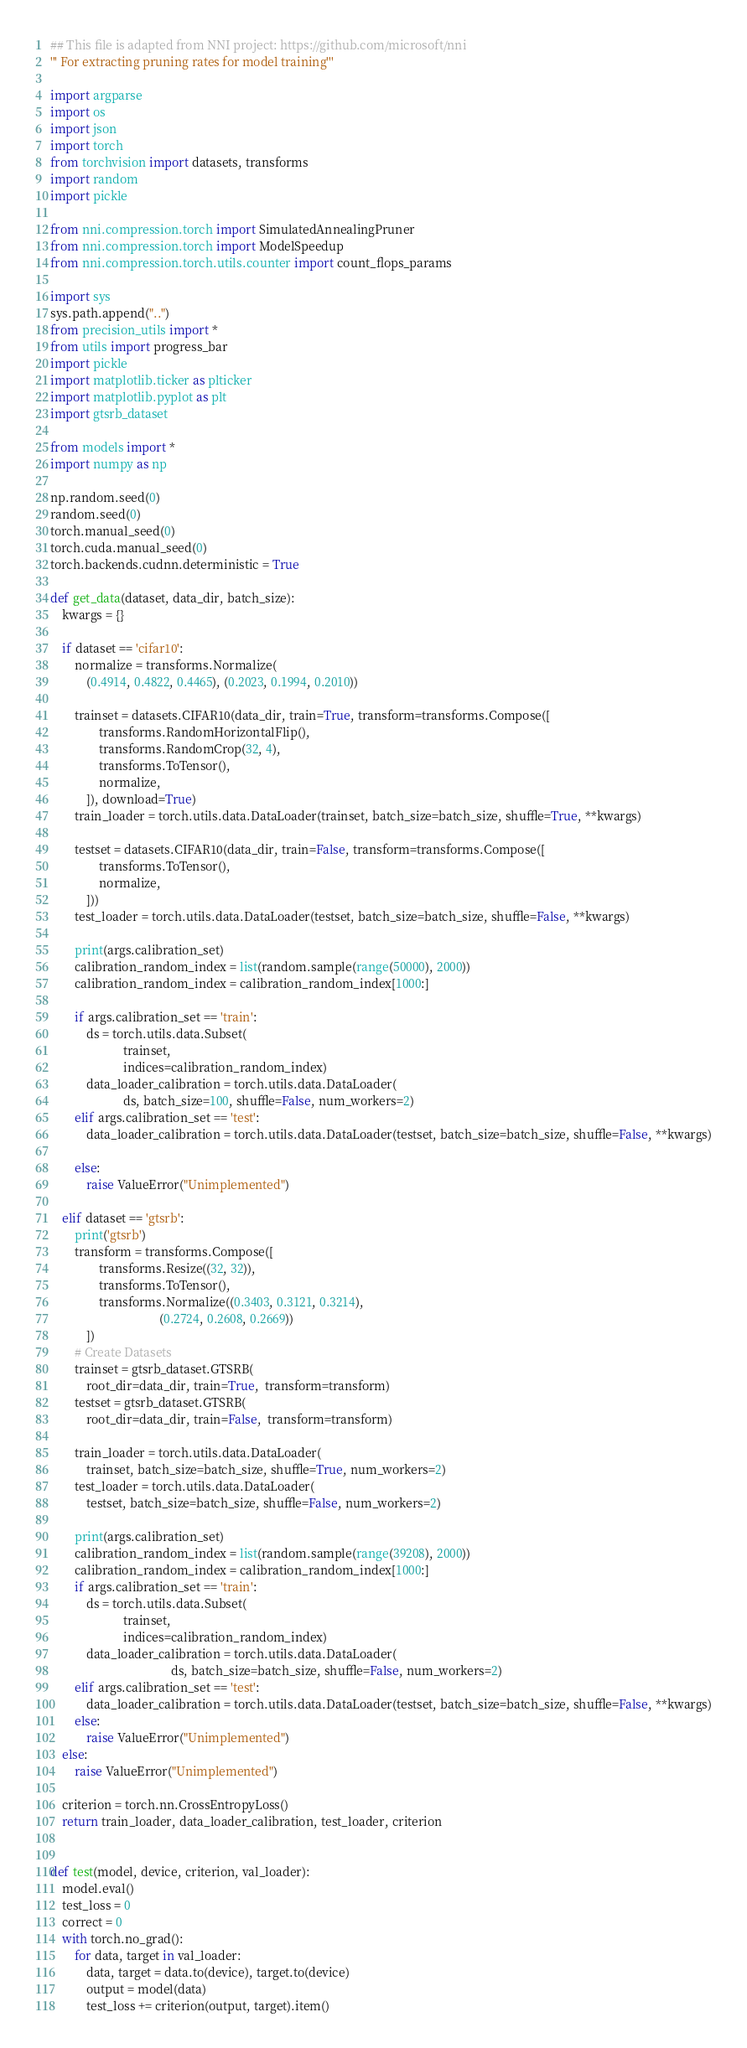Convert code to text. <code><loc_0><loc_0><loc_500><loc_500><_Python_>## This file is adapted from NNI project: https://github.com/microsoft/nni
''' For extracting pruning rates for model training'''

import argparse
import os
import json
import torch
from torchvision import datasets, transforms
import random
import pickle

from nni.compression.torch import SimulatedAnnealingPruner
from nni.compression.torch import ModelSpeedup
from nni.compression.torch.utils.counter import count_flops_params

import sys
sys.path.append("..")
from precision_utils import *
from utils import progress_bar
import pickle
import matplotlib.ticker as plticker
import matplotlib.pyplot as plt 
import gtsrb_dataset

from models import *
import numpy as np

np.random.seed(0)
random.seed(0)
torch.manual_seed(0)
torch.cuda.manual_seed(0)
torch.backends.cudnn.deterministic = True

def get_data(dataset, data_dir, batch_size):
    kwargs = {}

    if dataset == 'cifar10':
        normalize = transforms.Normalize(
            (0.4914, 0.4822, 0.4465), (0.2023, 0.1994, 0.2010))

        trainset = datasets.CIFAR10(data_dir, train=True, transform=transforms.Compose([
                transforms.RandomHorizontalFlip(),
                transforms.RandomCrop(32, 4),
                transforms.ToTensor(),
                normalize,
            ]), download=True)
        train_loader = torch.utils.data.DataLoader(trainset, batch_size=batch_size, shuffle=True, **kwargs)

        testset = datasets.CIFAR10(data_dir, train=False, transform=transforms.Compose([
                transforms.ToTensor(),
                normalize,
            ]))
        test_loader = torch.utils.data.DataLoader(testset, batch_size=batch_size, shuffle=False, **kwargs)

        print(args.calibration_set)
        calibration_random_index = list(random.sample(range(50000), 2000))
        calibration_random_index = calibration_random_index[1000:]

        if args.calibration_set == 'train':
            ds = torch.utils.data.Subset(
                        trainset,
                        indices=calibration_random_index)
            data_loader_calibration = torch.utils.data.DataLoader(
                        ds, batch_size=100, shuffle=False, num_workers=2)
        elif args.calibration_set == 'test':
            data_loader_calibration = torch.utils.data.DataLoader(testset, batch_size=batch_size, shuffle=False, **kwargs)

        else:
            raise ValueError("Unimplemented")

    elif dataset == 'gtsrb':
        print('gtsrb')
        transform = transforms.Compose([
                transforms.Resize((32, 32)),
                transforms.ToTensor(),
                transforms.Normalize((0.3403, 0.3121, 0.3214),
                                    (0.2724, 0.2608, 0.2669))
            ])
        # Create Datasets
        trainset = gtsrb_dataset.GTSRB(
            root_dir=data_dir, train=True,  transform=transform)
        testset = gtsrb_dataset.GTSRB(
            root_dir=data_dir, train=False,  transform=transform)

        train_loader = torch.utils.data.DataLoader(
            trainset, batch_size=batch_size, shuffle=True, num_workers=2)
        test_loader = torch.utils.data.DataLoader(
            testset, batch_size=batch_size, shuffle=False, num_workers=2)

        print(args.calibration_set)
        calibration_random_index = list(random.sample(range(39208), 2000))
        calibration_random_index = calibration_random_index[1000:]
        if args.calibration_set == 'train':
            ds = torch.utils.data.Subset(
                        trainset,
                        indices=calibration_random_index)
            data_loader_calibration = torch.utils.data.DataLoader(
                                        ds, batch_size=batch_size, shuffle=False, num_workers=2)
        elif args.calibration_set == 'test':
            data_loader_calibration = torch.utils.data.DataLoader(testset, batch_size=batch_size, shuffle=False, **kwargs)
        else:
            raise ValueError("Unimplemented")
    else:
        raise ValueError("Unimplemented")

    criterion = torch.nn.CrossEntropyLoss()
    return train_loader, data_loader_calibration, test_loader, criterion


def test(model, device, criterion, val_loader):
    model.eval()
    test_loss = 0
    correct = 0
    with torch.no_grad():
        for data, target in val_loader:
            data, target = data.to(device), target.to(device)
            output = model(data)
            test_loss += criterion(output, target).item()</code> 